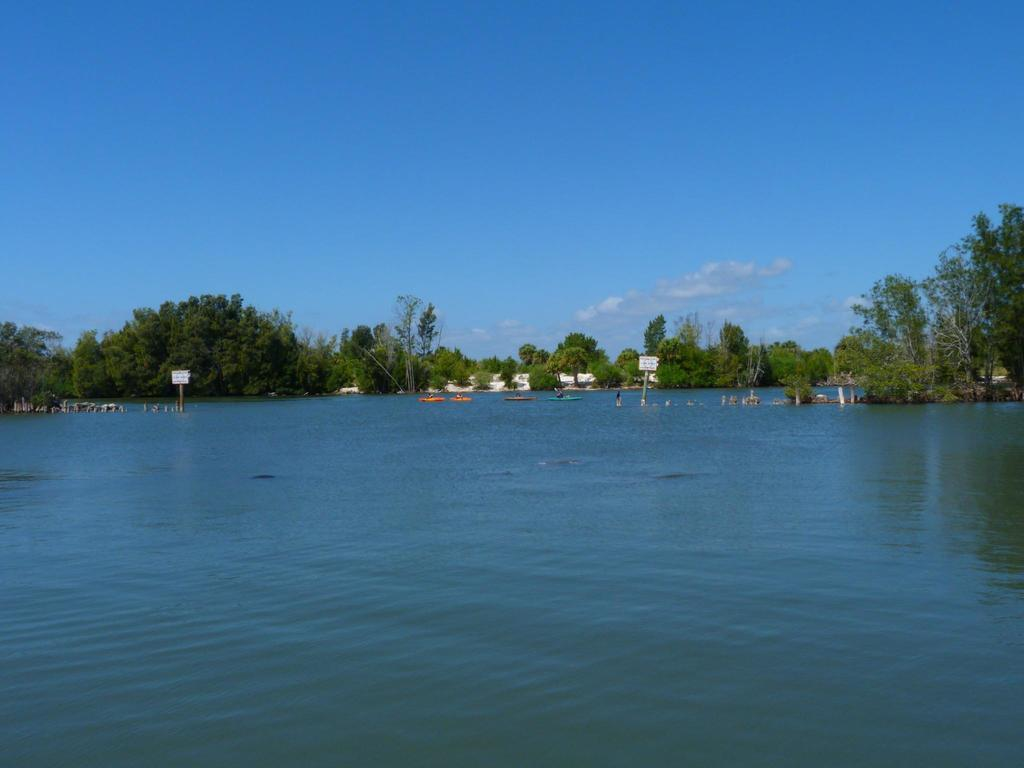What is visible in the image? Water is visible in the image. What can be seen in the background of the image? There are boats, trees, and clouds in the sky in the background of the image. What type of potato is being harvested in the image? There is no potato or any indication of farming in the image; it features water, boats, trees, and clouds. 